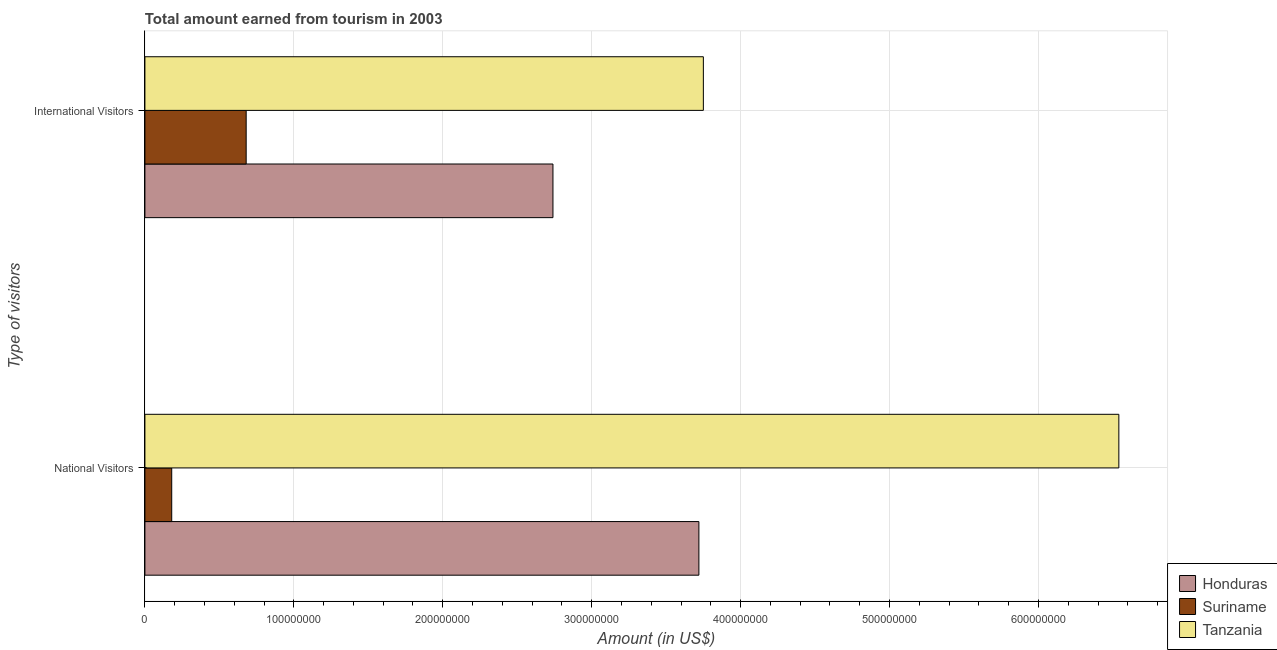How many groups of bars are there?
Your answer should be very brief. 2. How many bars are there on the 2nd tick from the bottom?
Provide a short and direct response. 3. What is the label of the 2nd group of bars from the top?
Provide a succinct answer. National Visitors. What is the amount earned from international visitors in Honduras?
Your response must be concise. 2.74e+08. Across all countries, what is the maximum amount earned from international visitors?
Your response must be concise. 3.75e+08. Across all countries, what is the minimum amount earned from international visitors?
Provide a short and direct response. 6.80e+07. In which country was the amount earned from international visitors maximum?
Provide a short and direct response. Tanzania. In which country was the amount earned from international visitors minimum?
Keep it short and to the point. Suriname. What is the total amount earned from international visitors in the graph?
Keep it short and to the point. 7.17e+08. What is the difference between the amount earned from national visitors in Honduras and that in Suriname?
Provide a succinct answer. 3.54e+08. What is the difference between the amount earned from international visitors in Suriname and the amount earned from national visitors in Honduras?
Provide a succinct answer. -3.04e+08. What is the average amount earned from international visitors per country?
Make the answer very short. 2.39e+08. What is the difference between the amount earned from national visitors and amount earned from international visitors in Tanzania?
Provide a short and direct response. 2.79e+08. What is the ratio of the amount earned from international visitors in Honduras to that in Tanzania?
Offer a very short reply. 0.73. Is the amount earned from international visitors in Tanzania less than that in Honduras?
Your response must be concise. No. In how many countries, is the amount earned from international visitors greater than the average amount earned from international visitors taken over all countries?
Your response must be concise. 2. What does the 2nd bar from the top in International Visitors represents?
Your response must be concise. Suriname. What does the 3rd bar from the bottom in National Visitors represents?
Give a very brief answer. Tanzania. How many countries are there in the graph?
Your answer should be compact. 3. What is the difference between two consecutive major ticks on the X-axis?
Your answer should be very brief. 1.00e+08. Does the graph contain any zero values?
Provide a short and direct response. No. Does the graph contain grids?
Your response must be concise. Yes. How are the legend labels stacked?
Provide a short and direct response. Vertical. What is the title of the graph?
Provide a short and direct response. Total amount earned from tourism in 2003. What is the label or title of the Y-axis?
Give a very brief answer. Type of visitors. What is the Amount (in US$) of Honduras in National Visitors?
Your response must be concise. 3.72e+08. What is the Amount (in US$) in Suriname in National Visitors?
Provide a short and direct response. 1.80e+07. What is the Amount (in US$) in Tanzania in National Visitors?
Keep it short and to the point. 6.54e+08. What is the Amount (in US$) in Honduras in International Visitors?
Keep it short and to the point. 2.74e+08. What is the Amount (in US$) in Suriname in International Visitors?
Your answer should be very brief. 6.80e+07. What is the Amount (in US$) in Tanzania in International Visitors?
Make the answer very short. 3.75e+08. Across all Type of visitors, what is the maximum Amount (in US$) in Honduras?
Your answer should be compact. 3.72e+08. Across all Type of visitors, what is the maximum Amount (in US$) in Suriname?
Keep it short and to the point. 6.80e+07. Across all Type of visitors, what is the maximum Amount (in US$) of Tanzania?
Offer a very short reply. 6.54e+08. Across all Type of visitors, what is the minimum Amount (in US$) of Honduras?
Provide a succinct answer. 2.74e+08. Across all Type of visitors, what is the minimum Amount (in US$) of Suriname?
Offer a terse response. 1.80e+07. Across all Type of visitors, what is the minimum Amount (in US$) of Tanzania?
Make the answer very short. 3.75e+08. What is the total Amount (in US$) of Honduras in the graph?
Your answer should be compact. 6.46e+08. What is the total Amount (in US$) of Suriname in the graph?
Make the answer very short. 8.60e+07. What is the total Amount (in US$) in Tanzania in the graph?
Your response must be concise. 1.03e+09. What is the difference between the Amount (in US$) in Honduras in National Visitors and that in International Visitors?
Provide a short and direct response. 9.80e+07. What is the difference between the Amount (in US$) in Suriname in National Visitors and that in International Visitors?
Make the answer very short. -5.00e+07. What is the difference between the Amount (in US$) of Tanzania in National Visitors and that in International Visitors?
Provide a short and direct response. 2.79e+08. What is the difference between the Amount (in US$) in Honduras in National Visitors and the Amount (in US$) in Suriname in International Visitors?
Your response must be concise. 3.04e+08. What is the difference between the Amount (in US$) in Honduras in National Visitors and the Amount (in US$) in Tanzania in International Visitors?
Offer a terse response. -3.00e+06. What is the difference between the Amount (in US$) in Suriname in National Visitors and the Amount (in US$) in Tanzania in International Visitors?
Keep it short and to the point. -3.57e+08. What is the average Amount (in US$) in Honduras per Type of visitors?
Provide a short and direct response. 3.23e+08. What is the average Amount (in US$) in Suriname per Type of visitors?
Provide a succinct answer. 4.30e+07. What is the average Amount (in US$) in Tanzania per Type of visitors?
Give a very brief answer. 5.14e+08. What is the difference between the Amount (in US$) of Honduras and Amount (in US$) of Suriname in National Visitors?
Offer a terse response. 3.54e+08. What is the difference between the Amount (in US$) in Honduras and Amount (in US$) in Tanzania in National Visitors?
Provide a succinct answer. -2.82e+08. What is the difference between the Amount (in US$) in Suriname and Amount (in US$) in Tanzania in National Visitors?
Keep it short and to the point. -6.36e+08. What is the difference between the Amount (in US$) of Honduras and Amount (in US$) of Suriname in International Visitors?
Make the answer very short. 2.06e+08. What is the difference between the Amount (in US$) of Honduras and Amount (in US$) of Tanzania in International Visitors?
Your response must be concise. -1.01e+08. What is the difference between the Amount (in US$) in Suriname and Amount (in US$) in Tanzania in International Visitors?
Make the answer very short. -3.07e+08. What is the ratio of the Amount (in US$) in Honduras in National Visitors to that in International Visitors?
Keep it short and to the point. 1.36. What is the ratio of the Amount (in US$) in Suriname in National Visitors to that in International Visitors?
Offer a very short reply. 0.26. What is the ratio of the Amount (in US$) of Tanzania in National Visitors to that in International Visitors?
Provide a succinct answer. 1.74. What is the difference between the highest and the second highest Amount (in US$) of Honduras?
Provide a succinct answer. 9.80e+07. What is the difference between the highest and the second highest Amount (in US$) of Tanzania?
Keep it short and to the point. 2.79e+08. What is the difference between the highest and the lowest Amount (in US$) in Honduras?
Offer a very short reply. 9.80e+07. What is the difference between the highest and the lowest Amount (in US$) of Suriname?
Make the answer very short. 5.00e+07. What is the difference between the highest and the lowest Amount (in US$) of Tanzania?
Keep it short and to the point. 2.79e+08. 